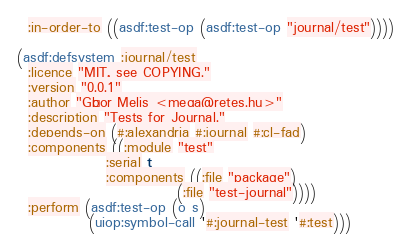<code> <loc_0><loc_0><loc_500><loc_500><_Lisp_>  :in-order-to ((asdf:test-op (asdf:test-op "journal/test"))))

(asdf:defsystem :journal/test
  :licence "MIT, see COPYING."
  :version "0.0.1"
  :author "Gábor Melis <mega@retes.hu>"
  :description "Tests for Journal."
  :depends-on (#:alexandria #:journal #:cl-fad)
  :components ((:module "test"
                :serial t
                :components ((:file "package")
                             (:file "test-journal"))))
  :perform (asdf:test-op (o s)
             (uiop:symbol-call '#:journal-test '#:test)))
</code> 